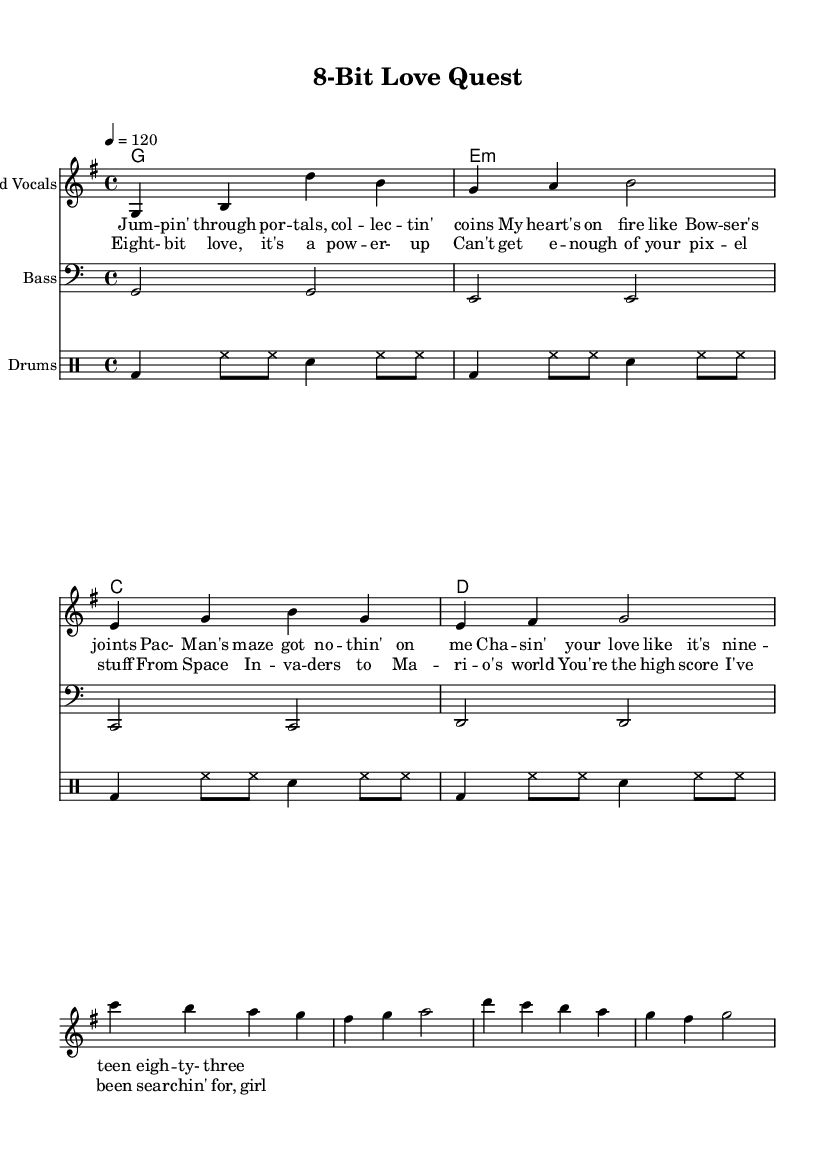What is the key signature of this music? The key signature is G major, which has one sharp (F#). This can be found at the beginning of the staff where the key is indicated.
Answer: G major What is the time signature of this music? The time signature is 4/4, which means there are four beats in each measure and the quarter note gets one beat. This is indicated at the beginning of the score.
Answer: 4/4 What is the tempo marking for this piece? The tempo marking is 120 beats per minute, shown at the top of the score indicating the speed of the piece.
Answer: 120 What chord follows the G chord in the verse? In the verse, the chord progression starts with G and is followed by E minor, as indicated in the chord symbols above the staff.
Answer: E minor How many measures are in the chorus of the song? The chorus contains four measures. By counting the measures with respective chord symbols from the provided notation, it can be confirmed.
Answer: 4 What is the lyrical theme referenced in the verse? The lyrics in the verse reference classic video game elements like collecting coins, which resembles characters from games such as Mario and Pac-Man. This theme draws a parallel between gaming and romance.
Answer: Collecting coins What video game character is mentioned in the lyrics? The lyrics specifically mention Bowser, a well-known character from the Super Mario series, indicating its thematic relation to video games.
Answer: Bowser 